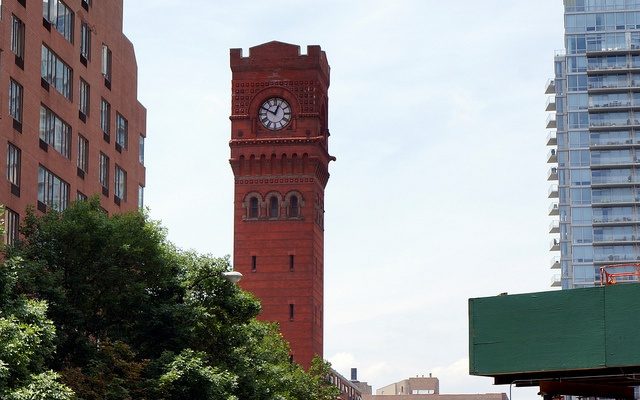Describe the objects in this image and their specific colors. I can see a clock in white, black, gray, and maroon tones in this image. 